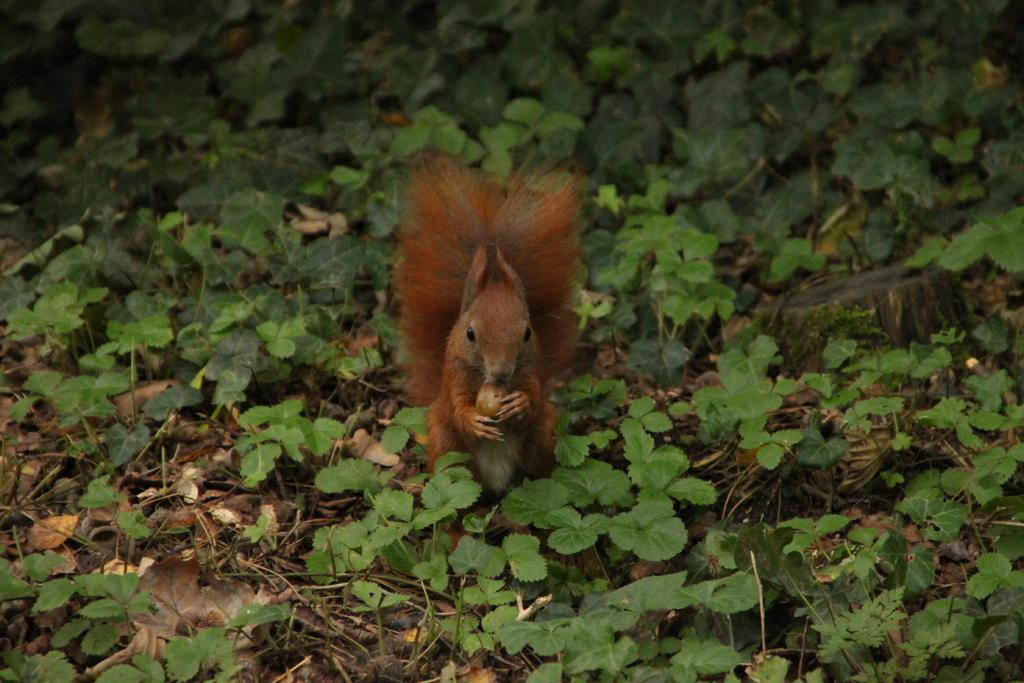What type of animal is in the image? There is an animal in the image, but its specific type cannot be determined from the provided facts. What colors can be seen on the animal? The animal has black, brown, and cream colors. What is the animal holding in the image? The animal is holding something, but the nature of the object cannot be determined from the provided facts. What type of vegetation is present in the image? There are green plants in the image. What additional objects can be seen in the image? Dry leaves and sticks are present in the image. What type of dinosaur can be seen holding a flag in the image? There is no dinosaur or flag present in the image. What type of rice is being cooked in the image? There is no rice present in the image. 